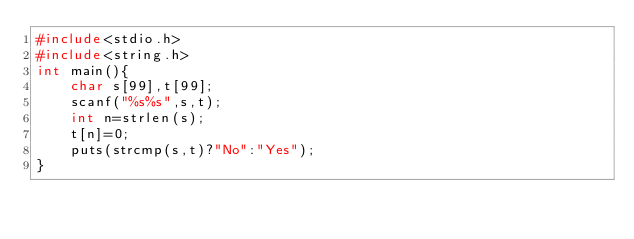Convert code to text. <code><loc_0><loc_0><loc_500><loc_500><_C_>#include<stdio.h>
#include<string.h>
int main(){
	char s[99],t[99];
	scanf("%s%s",s,t);
	int n=strlen(s);
	t[n]=0;
	puts(strcmp(s,t)?"No":"Yes");
}</code> 